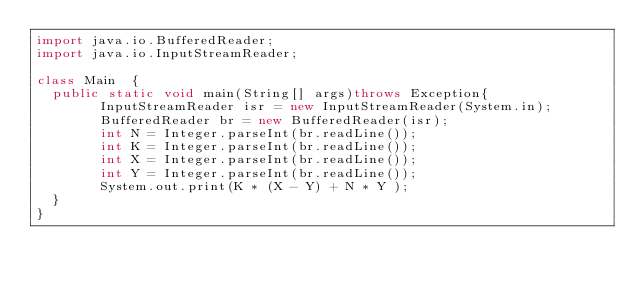Convert code to text. <code><loc_0><loc_0><loc_500><loc_500><_Java_>import java.io.BufferedReader;
import java.io.InputStreamReader;

class Main  {
	public static void main(String[] args)throws Exception{
        InputStreamReader isr = new InputStreamReader(System.in);
        BufferedReader br = new BufferedReader(isr);
        int N = Integer.parseInt(br.readLine());
        int K = Integer.parseInt(br.readLine());
        int X = Integer.parseInt(br.readLine());
        int Y = Integer.parseInt(br.readLine());
        System.out.print(K * (X - Y) + N * Y );
	}
}</code> 